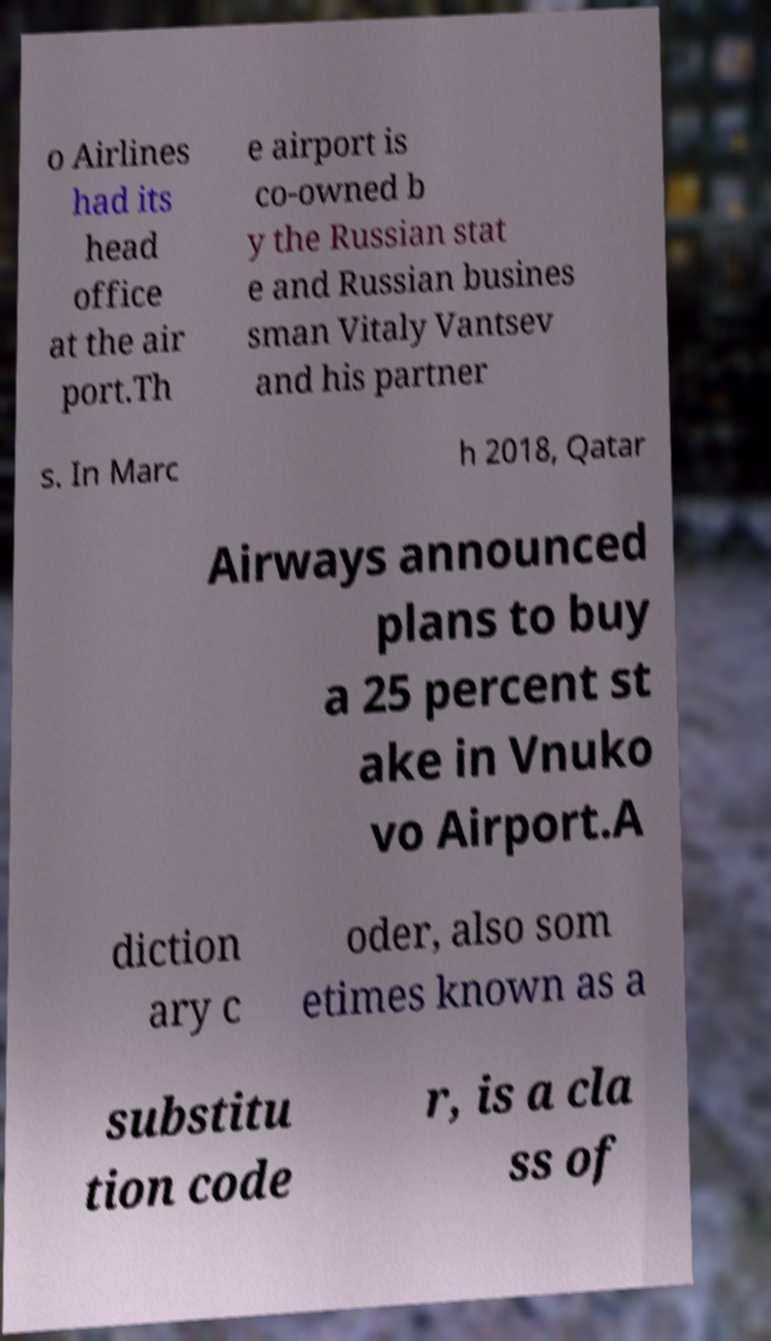There's text embedded in this image that I need extracted. Can you transcribe it verbatim? o Airlines had its head office at the air port.Th e airport is co-owned b y the Russian stat e and Russian busines sman Vitaly Vantsev and his partner s. In Marc h 2018, Qatar Airways announced plans to buy a 25 percent st ake in Vnuko vo Airport.A diction ary c oder, also som etimes known as a substitu tion code r, is a cla ss of 